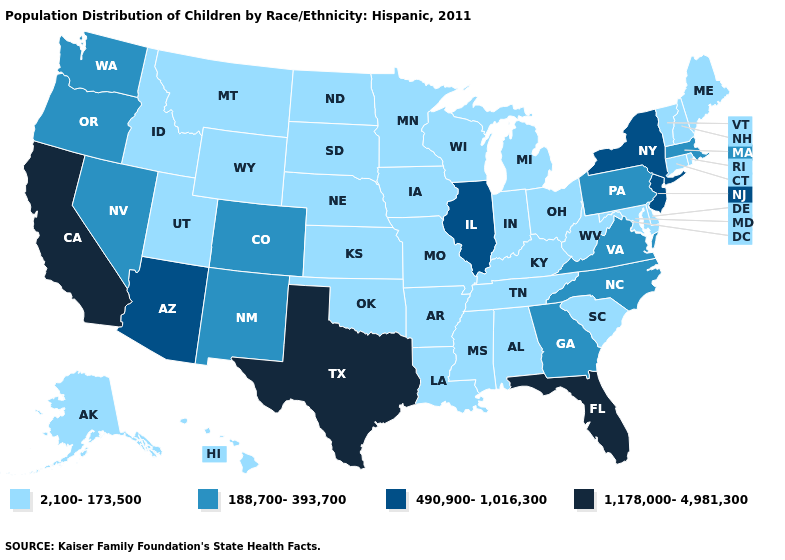Name the states that have a value in the range 490,900-1,016,300?
Be succinct. Arizona, Illinois, New Jersey, New York. Name the states that have a value in the range 1,178,000-4,981,300?
Write a very short answer. California, Florida, Texas. Does Nebraska have the same value as Illinois?
Give a very brief answer. No. What is the highest value in states that border Colorado?
Give a very brief answer. 490,900-1,016,300. Name the states that have a value in the range 490,900-1,016,300?
Concise answer only. Arizona, Illinois, New Jersey, New York. Among the states that border Louisiana , which have the highest value?
Keep it brief. Texas. What is the lowest value in states that border Iowa?
Be succinct. 2,100-173,500. What is the highest value in the Northeast ?
Give a very brief answer. 490,900-1,016,300. Does Mississippi have the lowest value in the USA?
Quick response, please. Yes. Among the states that border Alabama , does Georgia have the highest value?
Quick response, please. No. Is the legend a continuous bar?
Be succinct. No. Name the states that have a value in the range 490,900-1,016,300?
Answer briefly. Arizona, Illinois, New Jersey, New York. Does North Carolina have a lower value than New York?
Keep it brief. Yes. Name the states that have a value in the range 2,100-173,500?
Be succinct. Alabama, Alaska, Arkansas, Connecticut, Delaware, Hawaii, Idaho, Indiana, Iowa, Kansas, Kentucky, Louisiana, Maine, Maryland, Michigan, Minnesota, Mississippi, Missouri, Montana, Nebraska, New Hampshire, North Dakota, Ohio, Oklahoma, Rhode Island, South Carolina, South Dakota, Tennessee, Utah, Vermont, West Virginia, Wisconsin, Wyoming. 